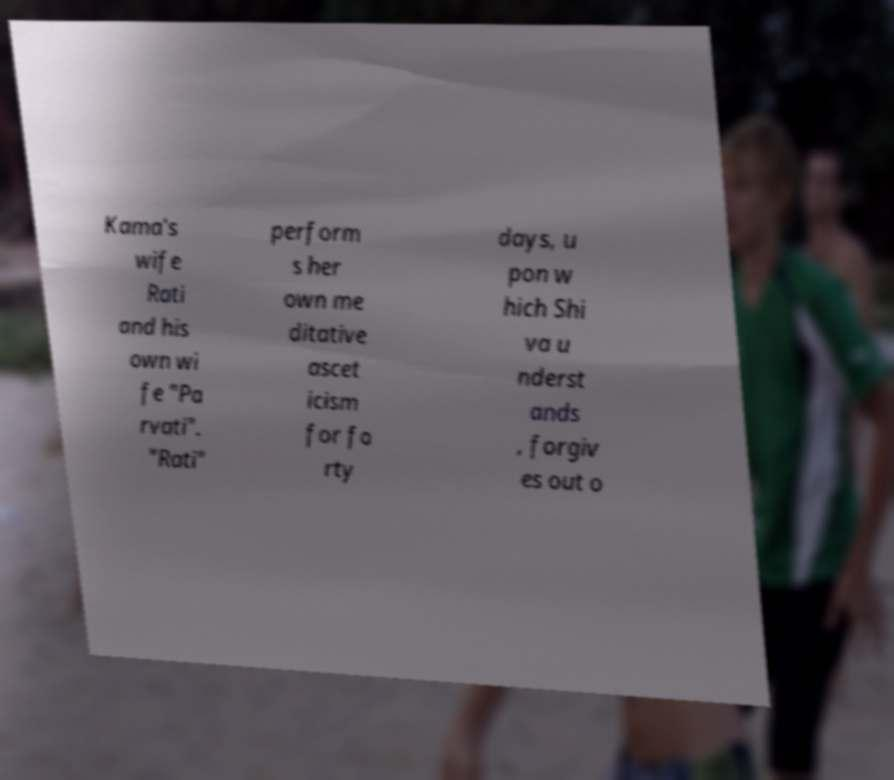Could you assist in decoding the text presented in this image and type it out clearly? Kama's wife Rati and his own wi fe "Pa rvati". "Rati" perform s her own me ditative ascet icism for fo rty days, u pon w hich Shi va u nderst ands , forgiv es out o 